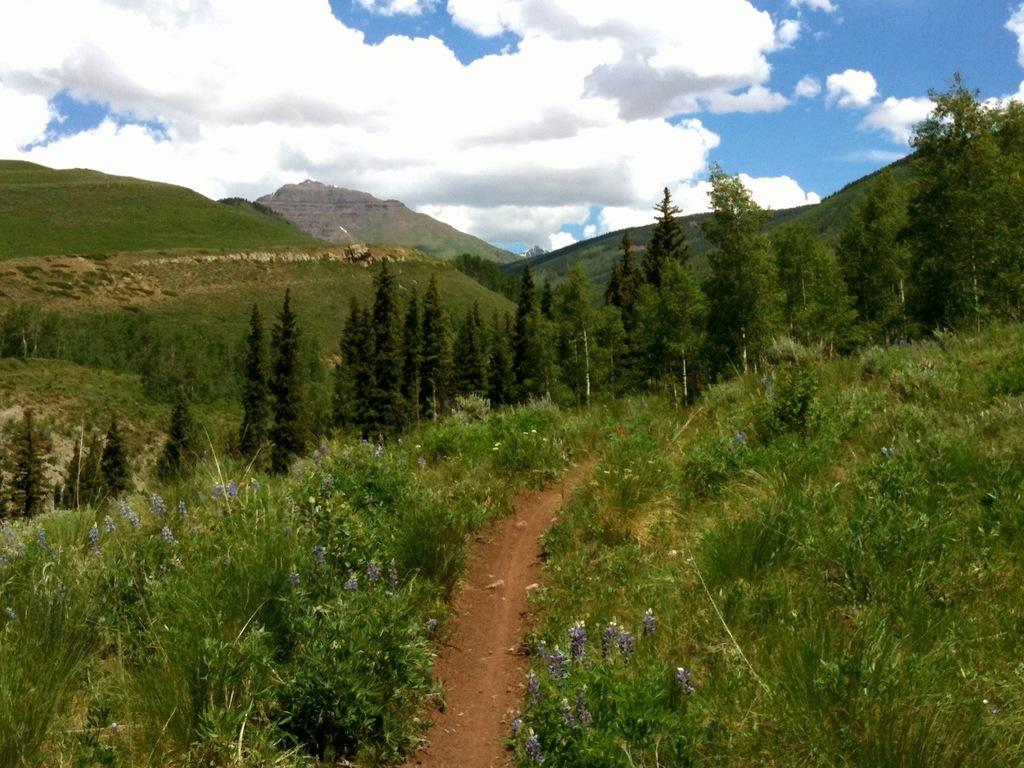What type of vegetation can be seen in the image? There is green grass in the image. What other natural elements are present in the image? There are trees visible in the image. What geographical feature can be seen in the image? There is a hill visible in the image. What is visible in the sky in the image? Clouds are present in the sky in the image. Where is the shelf located in the image? There is no shelf present in the image. Can you identify the actor in the image? There is no actor present in the image. 